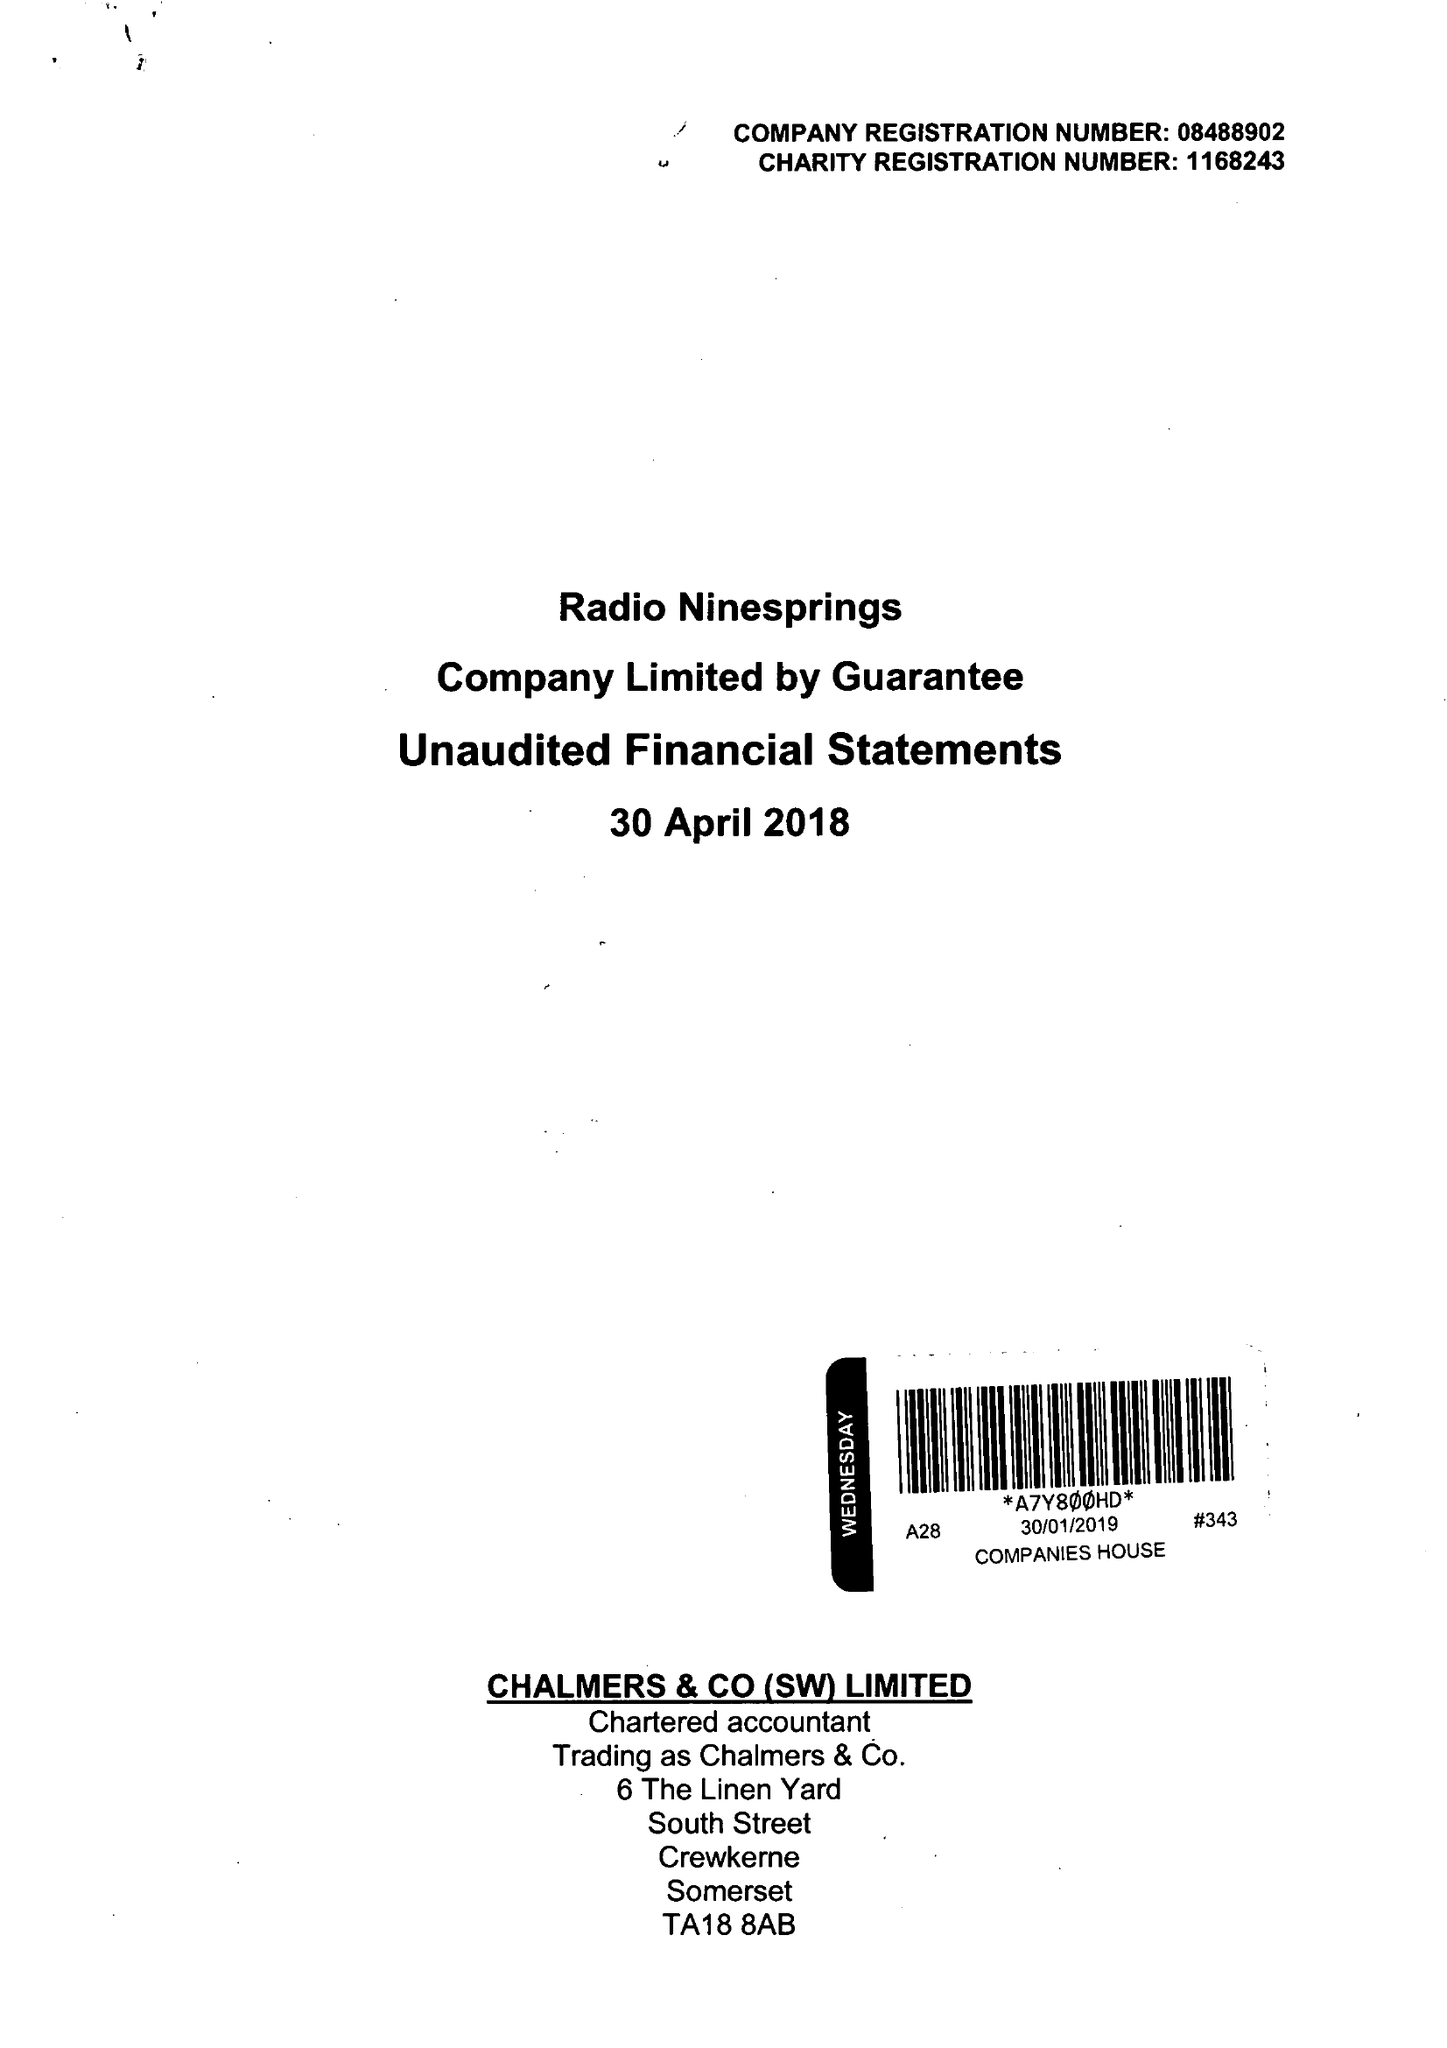What is the value for the charity_number?
Answer the question using a single word or phrase. 1168243 